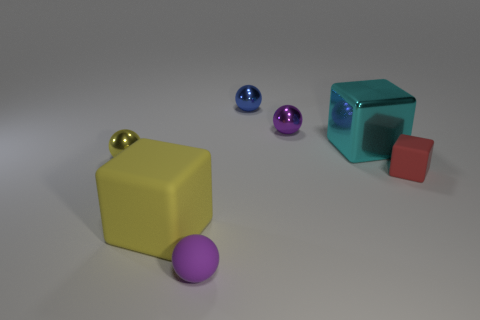Are there any other things that have the same material as the red object? Yes, the materials of the objects in the image appear to be similar, with a shiny and smooth surface. This indicates they could be made from similar plastics or polished metals. 